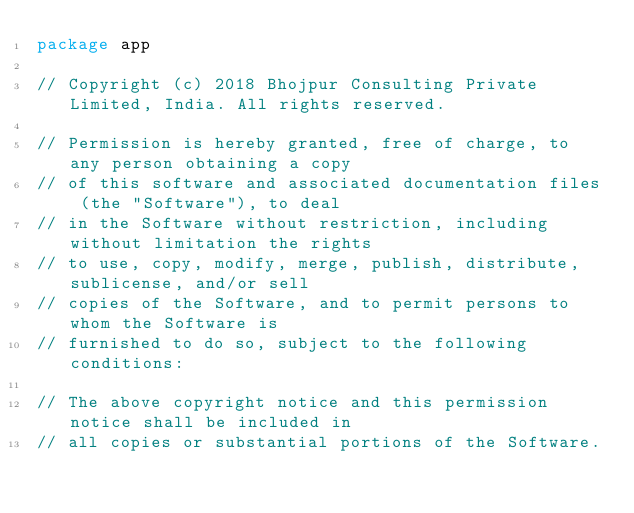<code> <loc_0><loc_0><loc_500><loc_500><_Go_>package app

// Copyright (c) 2018 Bhojpur Consulting Private Limited, India. All rights reserved.

// Permission is hereby granted, free of charge, to any person obtaining a copy
// of this software and associated documentation files (the "Software"), to deal
// in the Software without restriction, including without limitation the rights
// to use, copy, modify, merge, publish, distribute, sublicense, and/or sell
// copies of the Software, and to permit persons to whom the Software is
// furnished to do so, subject to the following conditions:

// The above copyright notice and this permission notice shall be included in
// all copies or substantial portions of the Software.
</code> 